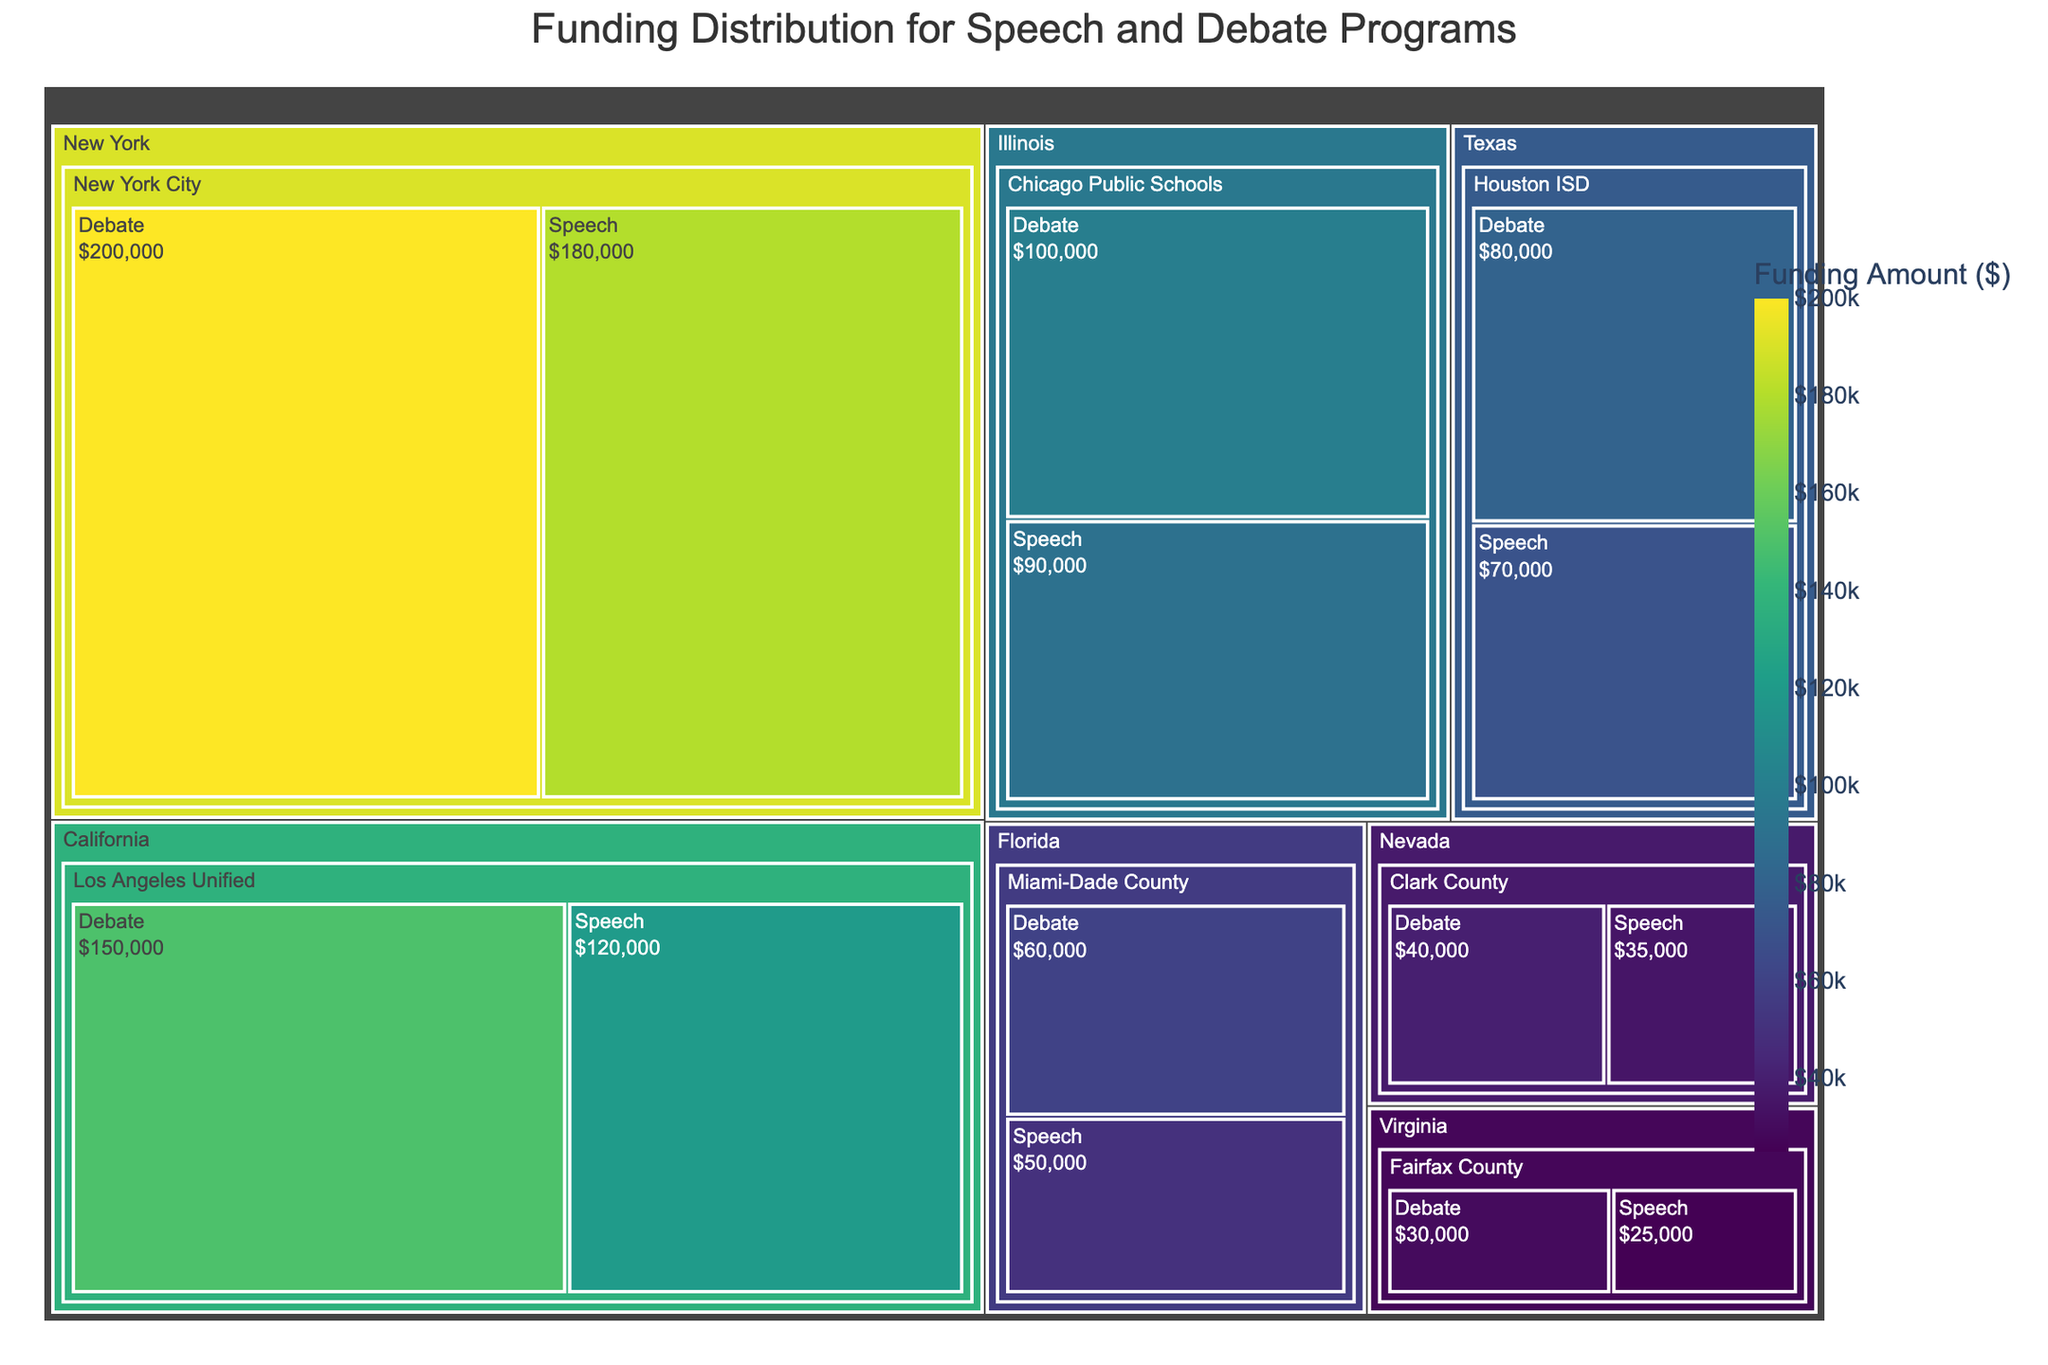What is the total funding amount for the New York City school district? Sum the funding amounts for both the debate and speech programs in the New York City school district (200,000 + 180,000).
Answer: 380,000 How does the funding for debate and speech programs compare in Fairfax County? Compare the funding amounts for the debate program (30,000) and the speech program (25,000) in Fairfax County by simply subtracting the smaller amount from the larger amount.
Answer: Debate has more funding by 5,000 Which state has the highest total funding for speech and debate programs combined? Sum the funding amounts for all school districts within each state, then compare to determine the state with the highest total. California has a total funding of 150,000 (debate) + 120,000 (speech) = 270,000, New York has 200,000 + 180,000 = 380,000 and so on. New York has the highest total funding.
Answer: New York What is the title of the treemap? The title of the treemap is usually displayed prominently at the top of the figure.
Answer: Funding Distribution for Speech and Debate Programs Which school district in Texas has the most funding, and what is the amount? Identify the funding amounts for school districts in Texas. Houston ISD is the only district in Texas, having 80,000 (debate) + 70,000 (speech). Hence, Houston ISD has the most funding.
Answer: Houston ISD, 150,000 Is the funding amount for speech programs in Miami-Dade County higher or lower than the debate programs there? Compare the funding amounts for speech (50,000) and debate (60,000) programs in Miami-Dade County.
Answer: Lower Which has more funding in Los Angeles Unified, the debate program or the speech program? Compare the funding amounts for the debate program (150,000) and the speech program (120,000) in Los Angeles Unified district.
Answer: Debate program 